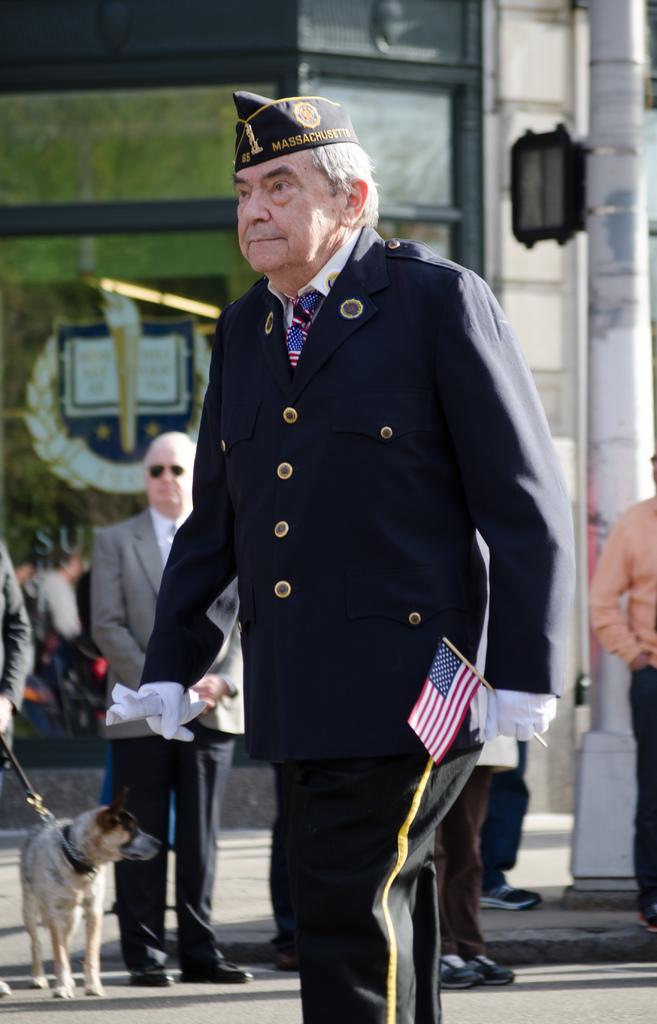Could you give a brief overview of what you see in this image? In the picture an old man is walking his holding an American flag in his hand he is wearing a hat in the background there is another person standing and there is a dog beside him,there is also a pole and a light fixed to that pole in the background there are some trees. 